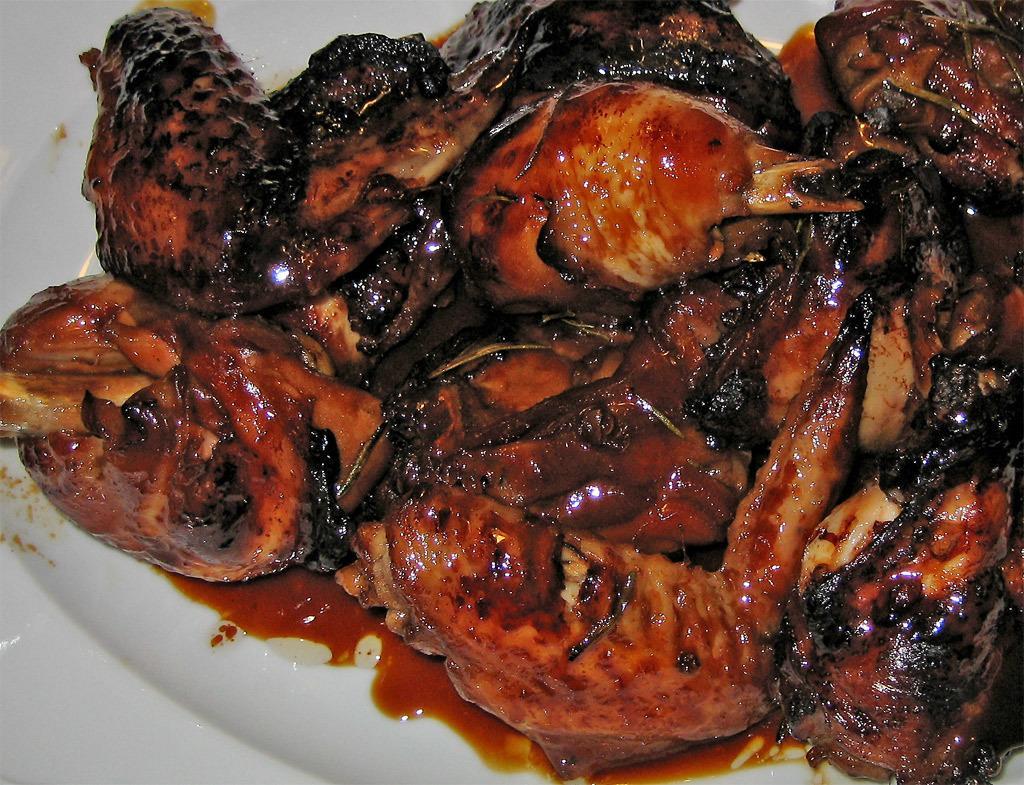How would you summarize this image in a sentence or two? In this image there is a plate, in that place there is a food item. 